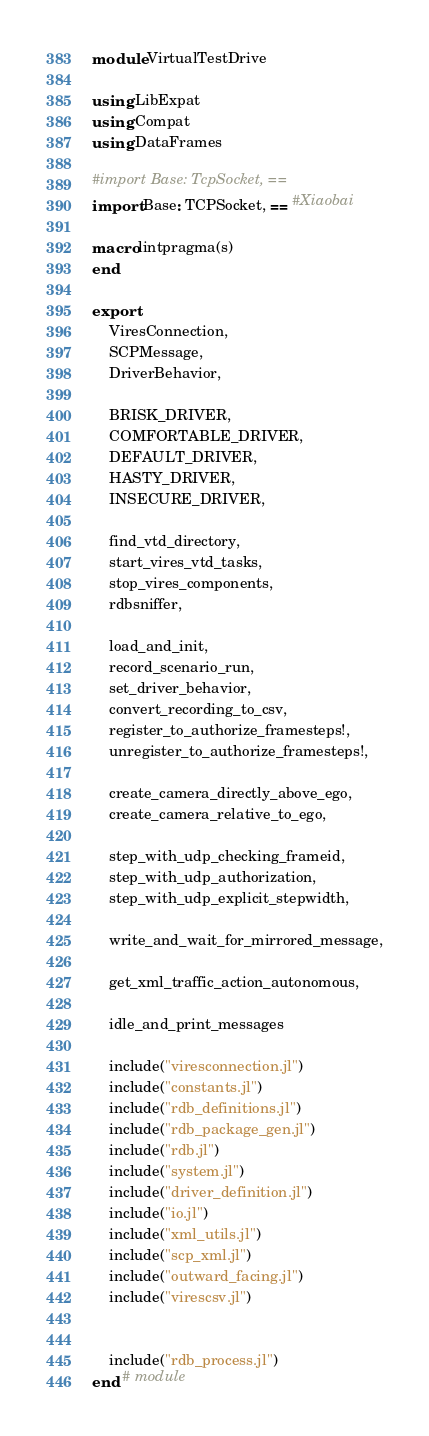<code> <loc_0><loc_0><loc_500><loc_500><_Julia_>module VirtualTestDrive
    
using LibExpat
using Compat
using DataFrames

#import Base: TcpSocket, ==
import Base: TCPSocket, == #Xiaobai

macro lintpragma(s)
end

export
    ViresConnection, 
    SCPMessage,
    DriverBehavior,

    BRISK_DRIVER,
    COMFORTABLE_DRIVER,
    DEFAULT_DRIVER,
    HASTY_DRIVER,
    INSECURE_DRIVER,

    find_vtd_directory,
    start_vires_vtd_tasks,
    stop_vires_components,
    rdbsniffer,

    load_and_init,
    record_scenario_run,
    set_driver_behavior,
    convert_recording_to_csv,
    register_to_authorize_framesteps!,
    unregister_to_authorize_framesteps!,

    create_camera_directly_above_ego,
    create_camera_relative_to_ego,
    
    step_with_udp_checking_frameid,
    step_with_udp_authorization,
    step_with_udp_explicit_stepwidth,

    write_and_wait_for_mirrored_message,

    get_xml_traffic_action_autonomous,
    
    idle_and_print_messages

    include("viresconnection.jl")
    include("constants.jl")
    include("rdb_definitions.jl")
    include("rdb_package_gen.jl")
    include("rdb.jl")
    include("system.jl")
    include("driver_definition.jl")
    include("io.jl")
    include("xml_utils.jl")
    include("scp_xml.jl")
    include("outward_facing.jl")
    include("virescsv.jl")


    include("rdb_process.jl")
end # module</code> 